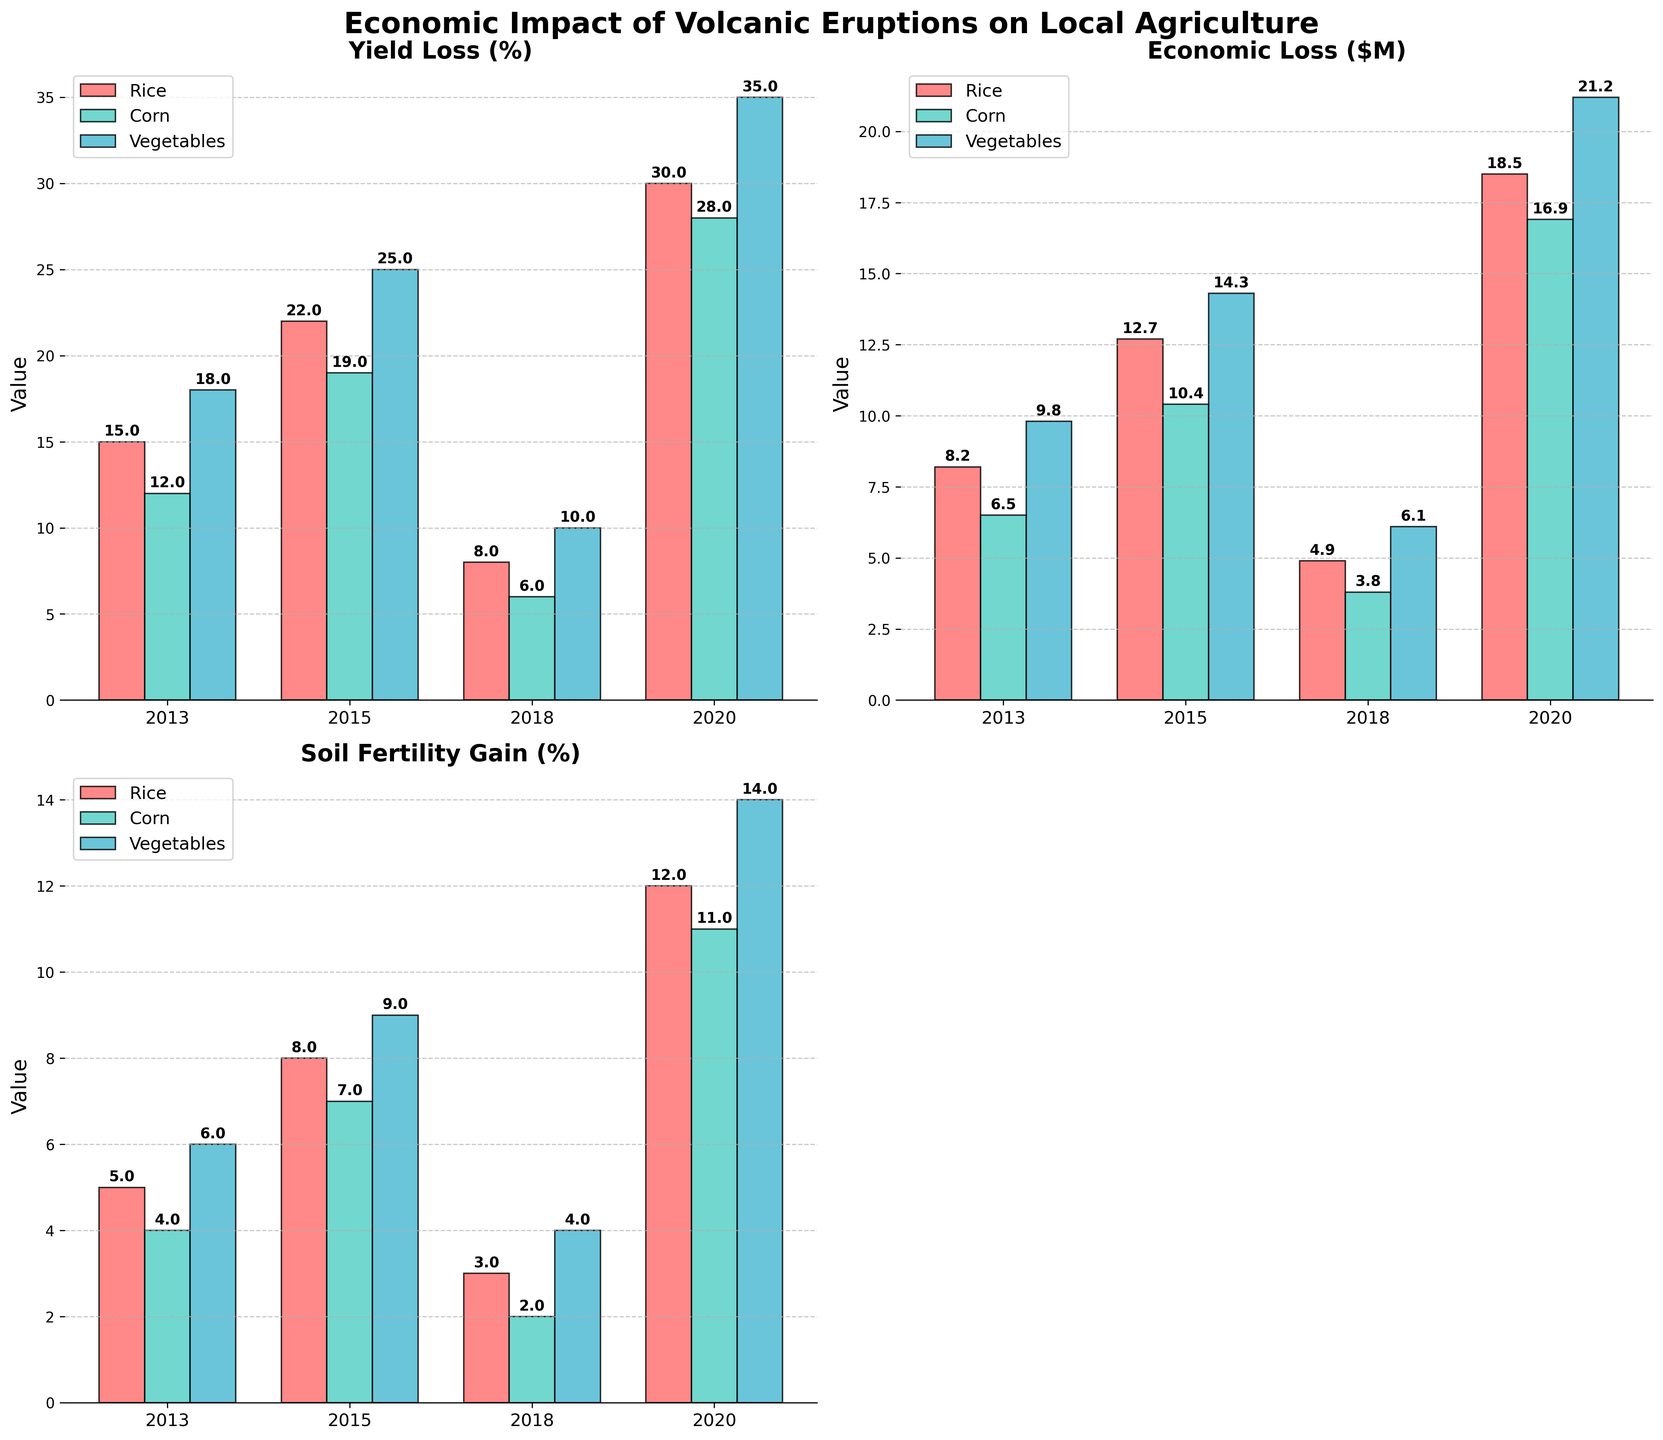What is the title of the figure? The figure’s title can be found at the top and it reads "Economic Impact of Volcanic Eruptions on Local Agriculture."
Answer: Economic Impact of Volcanic Eruptions on Local Agriculture How many types of crops are shown in the figure? The legend in each subplot shows the different crops represented, and there are three types: Rice, Corn, and Vegetables.
Answer: Three In which year did Rice experience the highest yield loss? By comparing the bars for Rice in the "Yield Loss (%)" subplot, the tallest bar for Rice is in 2020.
Answer: 2020 Which crop had the highest economic loss in 2015? In the "Economic Loss ($M)" subplot, among the bars for 2015, Vegetables have the highest bar.
Answer: Vegetables What was the soil fertility gain for Corn in 2018? By referring to the "Soil Fertility Gain (%)" subplot, the bar for Corn in 2018 is labeled, showing a value of 2%.
Answer: 2% Which year showed the lowest yield loss for Vegetables? In the "Yield Loss (%)" subplot, comparing the bars for Vegetables, the lowest bar is in 2018.
Answer: 2018 What is the difference in economic loss for Rice between 2015 and 2020? In the "Economic Loss ($M)" subplot, the bars for Rice in 2015 and 2020 show values of 12.7 and 18.5 million respectively; the difference is 18.5 - 12.7 = 5.8.
Answer: 5.8 million Compare the yield loss of Corn in 2013 and 2018. Which year had a greater loss? Looking at the "Yield Loss (%)" subplot, the bar for Corn in 2013 is taller than in 2018, indicating greater loss in 2013.
Answer: 2013 What is the total soil fertility gain for Rice over all the years? Adding up the soil fertility gain percentages for Rice across all years: 5 + 8 + 3 + 12 = 28.
Answer: 28% What was the economic loss for Vegetables in 2020, and how does it compare to Corn in the same year? In the "Economic Loss ($M)" subplot, Vegetables in 2020 had a loss of 21.2 million dollars, while Corn had 16.9 million dollars; Vegetables had a higher loss.
Answer: Vegetables had a higher loss with 21.2 million dollars 